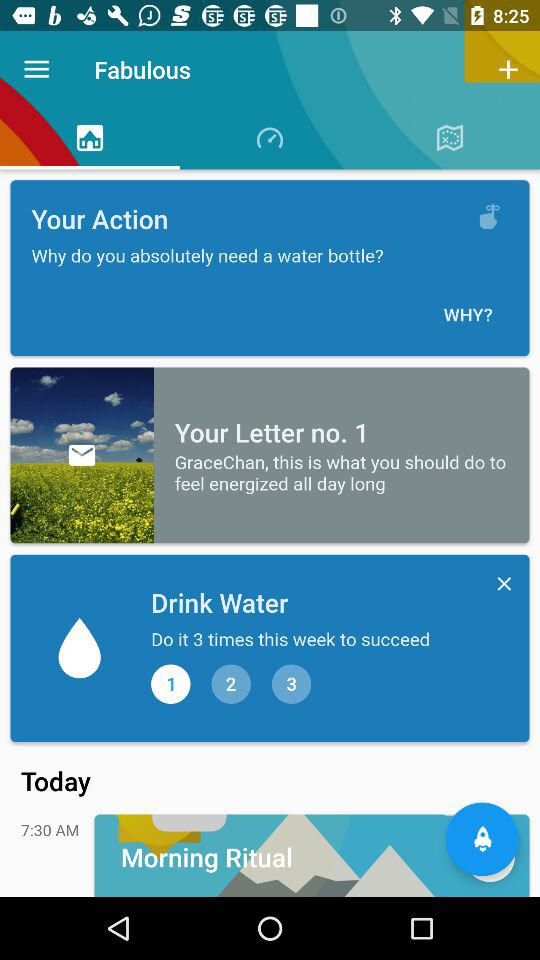How many times a week do I need to complete the task?
Answer the question using a single word or phrase. 3 